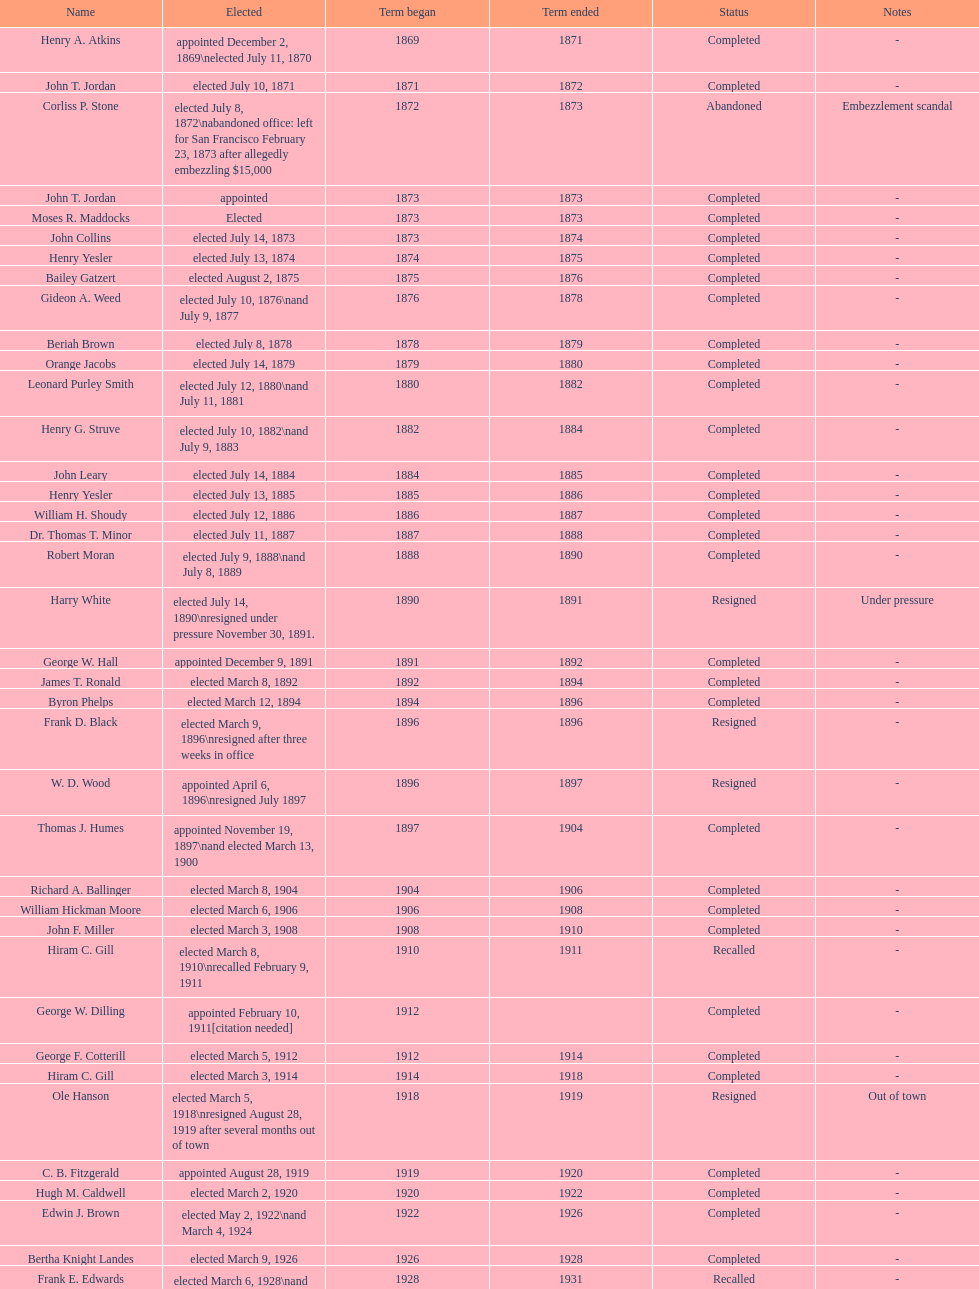What is the number of mayors with the first name of john? 6. 